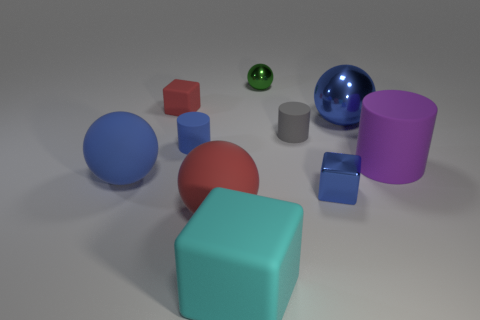Subtract all yellow balls. Subtract all brown blocks. How many balls are left? 4 Subtract all balls. How many objects are left? 6 Subtract 0 red cylinders. How many objects are left? 10 Subtract all large blue shiny cylinders. Subtract all small rubber cubes. How many objects are left? 9 Add 5 tiny gray cylinders. How many tiny gray cylinders are left? 6 Add 3 tiny rubber cubes. How many tiny rubber cubes exist? 4 